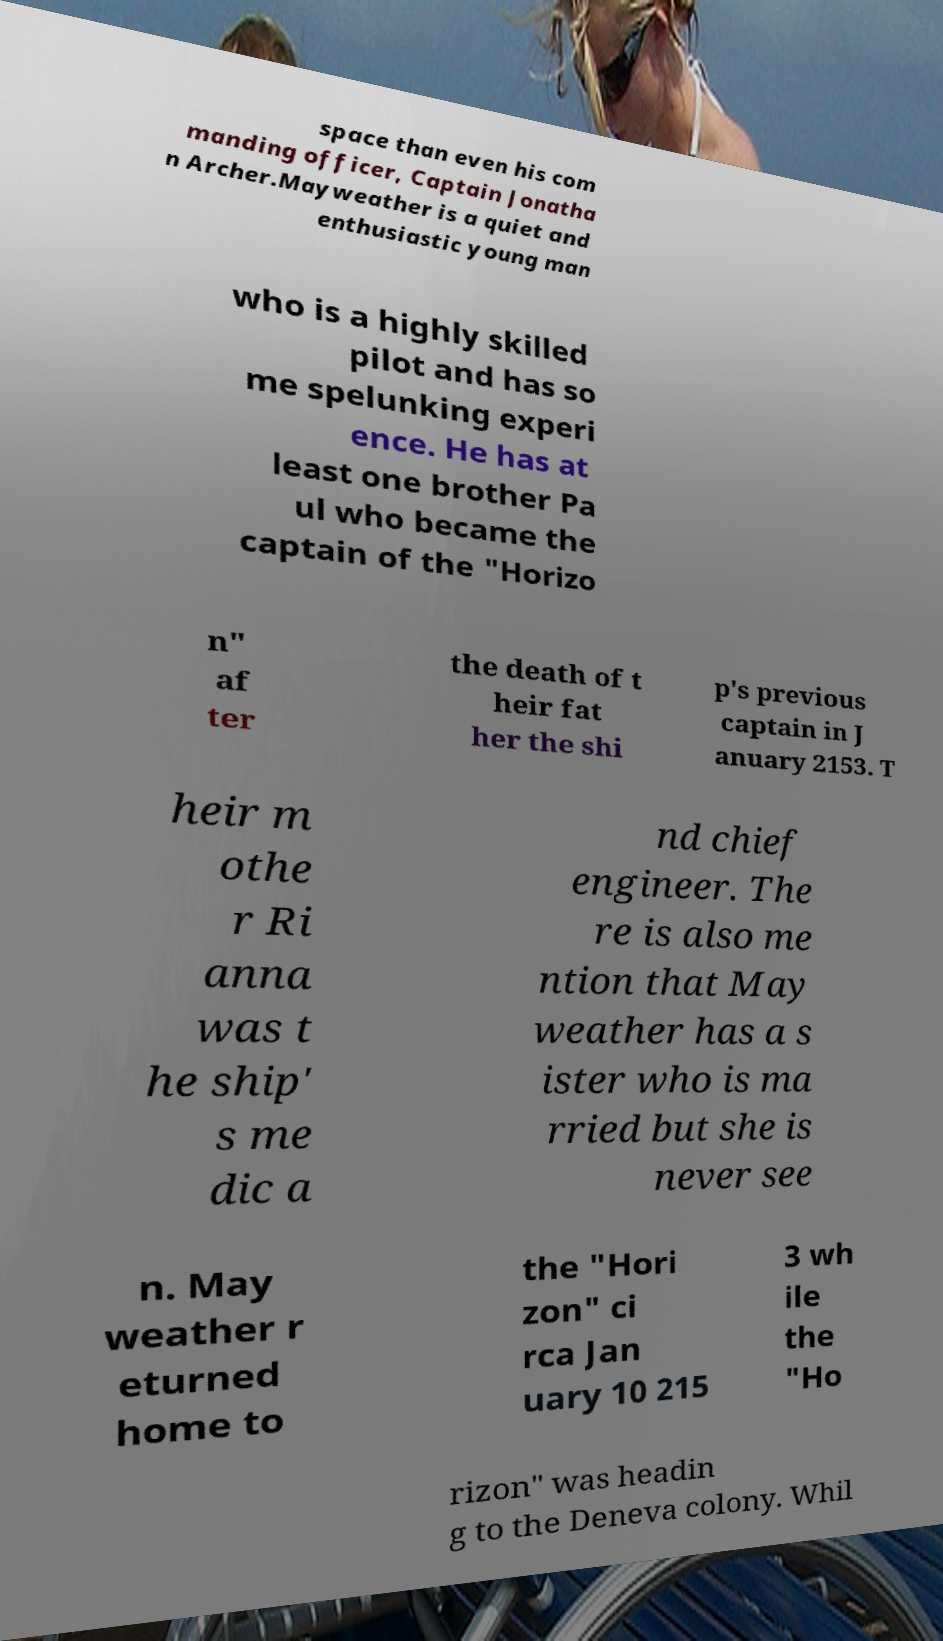I need the written content from this picture converted into text. Can you do that? space than even his com manding officer, Captain Jonatha n Archer.Mayweather is a quiet and enthusiastic young man who is a highly skilled pilot and has so me spelunking experi ence. He has at least one brother Pa ul who became the captain of the "Horizo n" af ter the death of t heir fat her the shi p's previous captain in J anuary 2153. T heir m othe r Ri anna was t he ship' s me dic a nd chief engineer. The re is also me ntion that May weather has a s ister who is ma rried but she is never see n. May weather r eturned home to the "Hori zon" ci rca Jan uary 10 215 3 wh ile the "Ho rizon" was headin g to the Deneva colony. Whil 